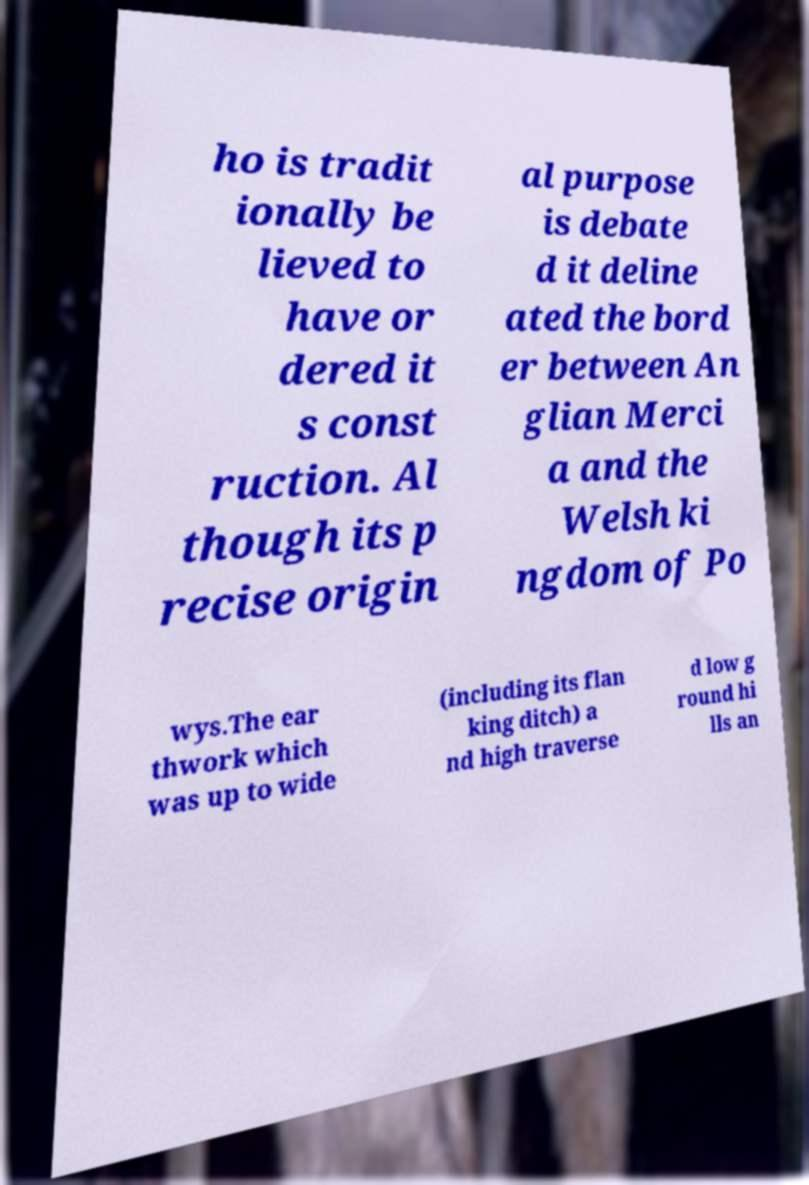For documentation purposes, I need the text within this image transcribed. Could you provide that? ho is tradit ionally be lieved to have or dered it s const ruction. Al though its p recise origin al purpose is debate d it deline ated the bord er between An glian Merci a and the Welsh ki ngdom of Po wys.The ear thwork which was up to wide (including its flan king ditch) a nd high traverse d low g round hi lls an 